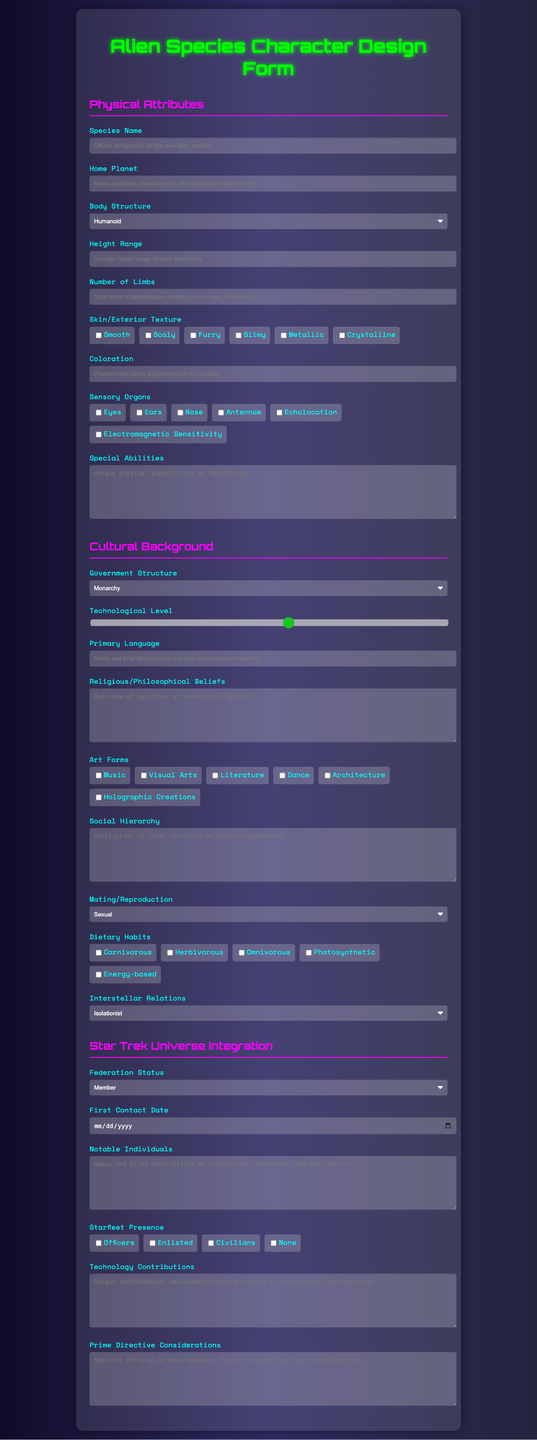what is the title of the form? The title is indicated at the top of the document, stating the purpose of the form.
Answer: Alien Species Character Design Form what are the options for body structure? The body structure options are listed in the Physical Attributes section and provide distinct categories.
Answer: Humanoid, Insectoid, Reptilian, Avian, Amorphous, Other what is the height range of the species? The height range is specified in meters and corresponds to the Body Structure section of the form.
Answer: Average height range of adult specimens which government structure types are available? The dropdown for government structure presents different possible societal organizations for the species.
Answer: Monarchy, Democracy, Oligarchy, Hive Mind, Anarchy, Federation what is the technology level scale range? The technology level is assessed on a numeric scale that indicates advancement, from beginner to highly advanced.
Answer: 1 to 10 what does the dietary habits section offer? This section allows multiple selection to specify the types of diets the species follows, displaying distinct categories.
Answer: Carnivorous, Herbivorous, Omnivorous, Photosynthetic, Energy-based what does interstellar relations describe? The dropdown menu offers various attitudes that the species might have towards other civilizations.
Answer: Isolationist, Diplomatic, Aggressive, Trade-focused, Expansionist which checkbox options are provided for Starfleet presence? The options available indicate the species' involvement in Starfleet operations and display distinct categories.
Answer: Officers, Enlisted, Civilians, None what is the purpose of the Prime Directive considerations section? This section examines specific cultural or developmental factors relevant to the Prime Directive within the context of the species.
Answer: Relevant cultural or developmental factors 